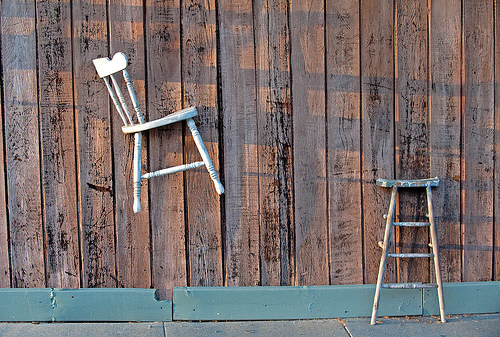<image>
Is there a chair in front of the board? Yes. The chair is positioned in front of the board, appearing closer to the camera viewpoint. 